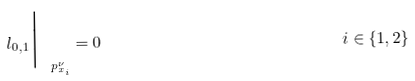Convert formula to latex. <formula><loc_0><loc_0><loc_500><loc_500>l _ { 0 , 1 } \Big | _ { \ p ^ { \nu } _ { x _ { i } } } & = 0 & & \quad i \in \{ 1 , 2 \}</formula> 